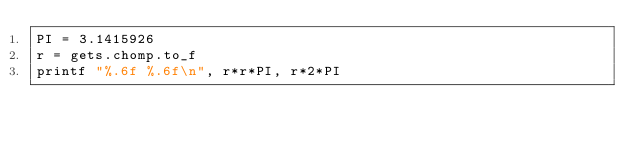Convert code to text. <code><loc_0><loc_0><loc_500><loc_500><_Ruby_>PI = 3.1415926
r = gets.chomp.to_f
printf "%.6f %.6f\n", r*r*PI, r*2*PI</code> 